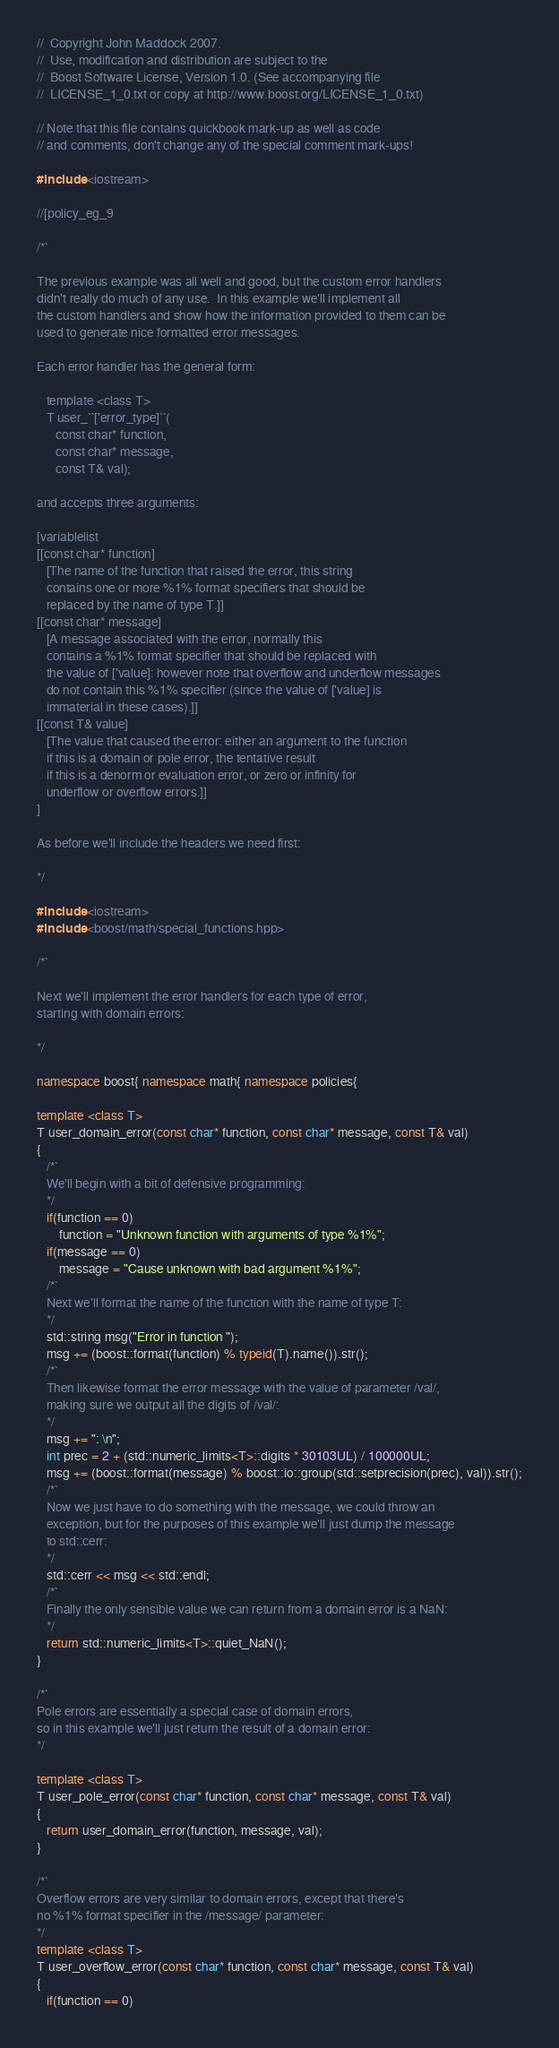<code> <loc_0><loc_0><loc_500><loc_500><_C++_>//  Copyright John Maddock 2007.
//  Use, modification and distribution are subject to the
//  Boost Software License, Version 1.0. (See accompanying file
//  LICENSE_1_0.txt or copy at http://www.boost.org/LICENSE_1_0.txt)

// Note that this file contains quickbook mark-up as well as code
// and comments, don't change any of the special comment mark-ups!

#include <iostream>

//[policy_eg_9

/*`

The previous example was all well and good, but the custom error handlers
didn't really do much of any use.  In this example we'll implement all
the custom handlers and show how the information provided to them can be
used to generate nice formatted error messages.

Each error handler has the general form:

   template <class T>
   T user_``['error_type]``(
      const char* function, 
      const char* message, 
      const T& val);

and accepts three arguments:

[variablelist
[[const char* function]
   [The name of the function that raised the error, this string
   contains one or more %1% format specifiers that should be
   replaced by the name of type T.]]
[[const char* message]
   [A message associated with the error, normally this
   contains a %1% format specifier that should be replaced with
   the value of ['value]: however note that overflow and underflow messages
   do not contain this %1% specifier (since the value of ['value] is
   immaterial in these cases).]]
[[const T& value]
   [The value that caused the error: either an argument to the function
   if this is a domain or pole error, the tentative result
   if this is a denorm or evaluation error, or zero or infinity for
   underflow or overflow errors.]]
]

As before we'll include the headers we need first:

*/

#include <iostream>
#include <boost/math/special_functions.hpp>

/*`

Next we'll implement the error handlers for each type of error, 
starting with domain errors:

*/

namespace boost{ namespace math{ namespace policies{

template <class T>
T user_domain_error(const char* function, const char* message, const T& val)
{
   /*`
   We'll begin with a bit of defensive programming:
   */
   if(function == 0)
       function = "Unknown function with arguments of type %1%";
   if(message == 0)
       message = "Cause unknown with bad argument %1%";
   /*`
   Next we'll format the name of the function with the name of type T:
   */
   std::string msg("Error in function ");
   msg += (boost::format(function) % typeid(T).name()).str();
   /*`
   Then likewise format the error message with the value of parameter /val/,
   making sure we output all the digits of /val/:
   */
   msg += ": \n";
   int prec = 2 + (std::numeric_limits<T>::digits * 30103UL) / 100000UL;
   msg += (boost::format(message) % boost::io::group(std::setprecision(prec), val)).str();
   /*`
   Now we just have to do something with the message, we could throw an 
   exception, but for the purposes of this example we'll just dump the message
   to std::cerr:
   */
   std::cerr << msg << std::endl;
   /*`
   Finally the only sensible value we can return from a domain error is a NaN:
   */
   return std::numeric_limits<T>::quiet_NaN();
}

/*`
Pole errors are essentially a special case of domain errors, 
so in this example we'll just return the result of a domain error:
*/

template <class T>
T user_pole_error(const char* function, const char* message, const T& val)
{
   return user_domain_error(function, message, val);
}

/*`
Overflow errors are very similar to domain errors, except that there's
no %1% format specifier in the /message/ parameter:
*/
template <class T>
T user_overflow_error(const char* function, const char* message, const T& val)
{
   if(function == 0)</code> 